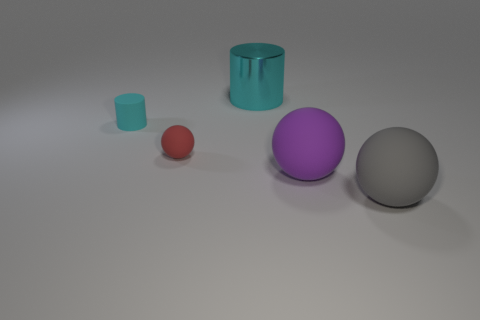Subtract 1 balls. How many balls are left? 2 Subtract all big spheres. How many spheres are left? 1 Add 2 tiny red metallic cylinders. How many objects exist? 7 Subtract all cylinders. How many objects are left? 3 Add 4 cyan metal objects. How many cyan metal objects exist? 5 Subtract 0 brown cylinders. How many objects are left? 5 Subtract all small shiny things. Subtract all gray balls. How many objects are left? 4 Add 4 large cyan metallic cylinders. How many large cyan metallic cylinders are left? 5 